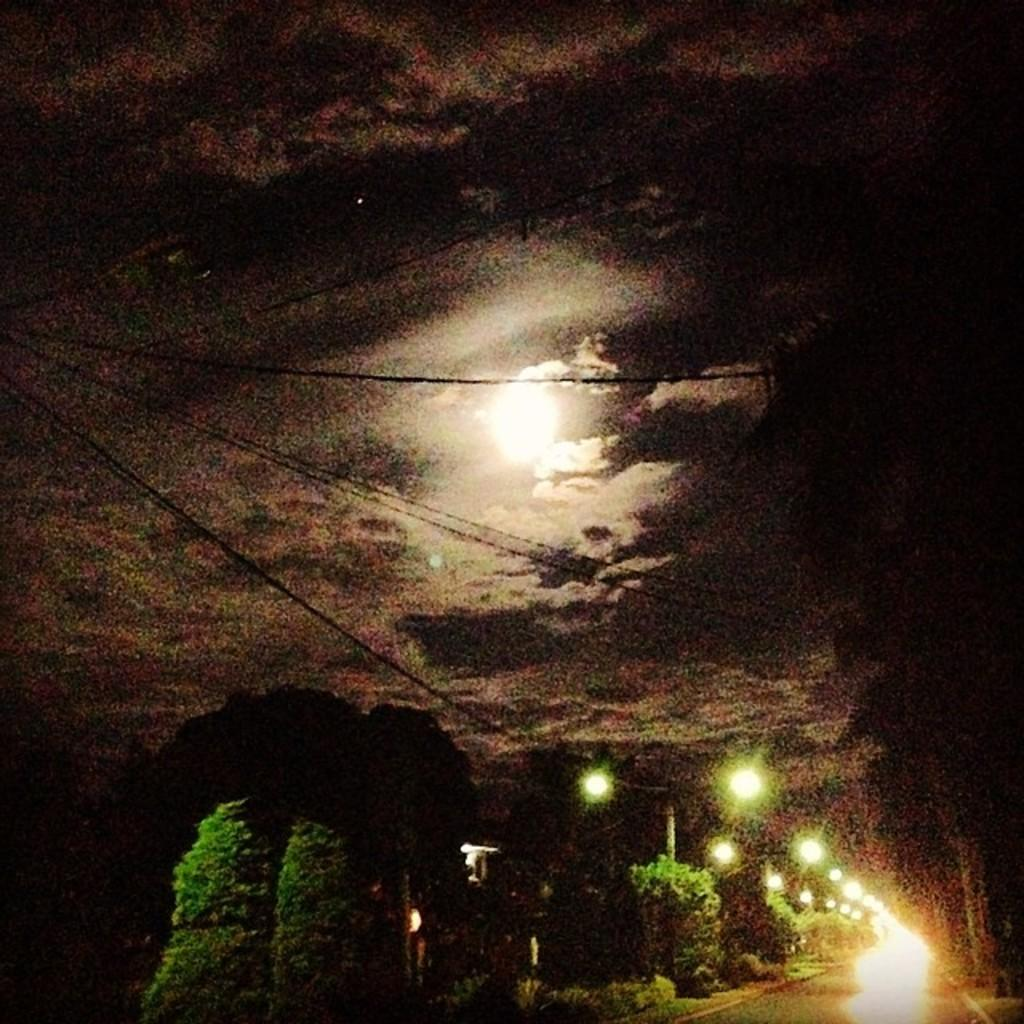What is located in the bottom right hand corner of the image? There is a road in the bottom right hand corner of the image. What can be seen in the middle of the image? There is a moon in the middle of the image. What is the background of the image? The background of the image is the sky. What type of polish is being applied to the collar in the image? There is no polish or collar present in the image; it features a road and a moon in the sky. 